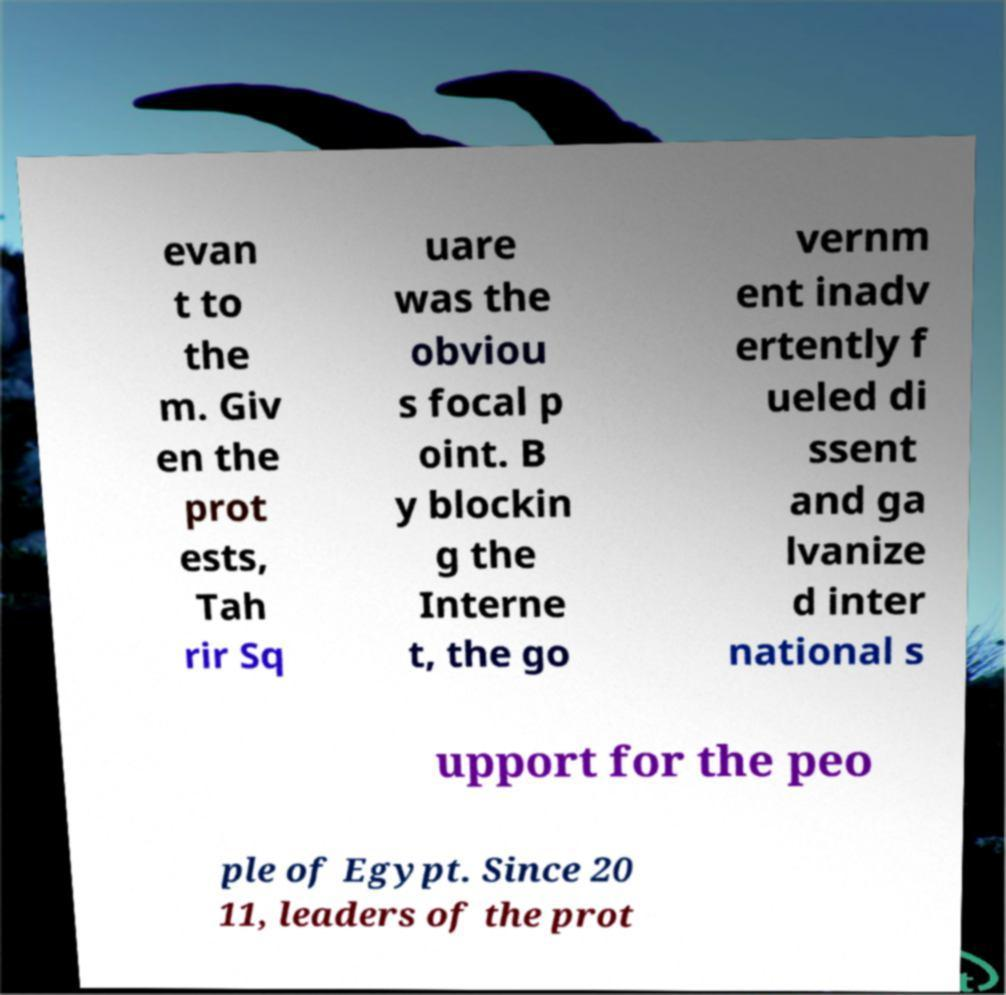What messages or text are displayed in this image? I need them in a readable, typed format. evan t to the m. Giv en the prot ests, Tah rir Sq uare was the obviou s focal p oint. B y blockin g the Interne t, the go vernm ent inadv ertently f ueled di ssent and ga lvanize d inter national s upport for the peo ple of Egypt. Since 20 11, leaders of the prot 